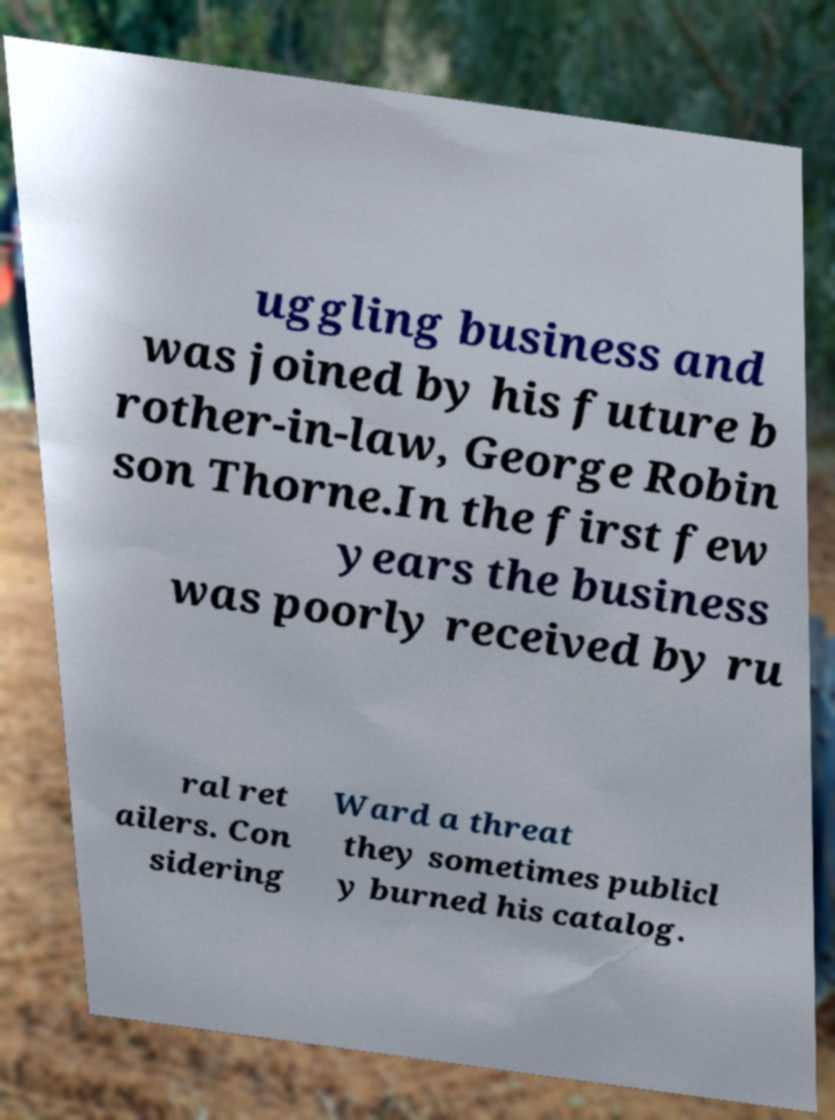What messages or text are displayed in this image? I need them in a readable, typed format. uggling business and was joined by his future b rother-in-law, George Robin son Thorne.In the first few years the business was poorly received by ru ral ret ailers. Con sidering Ward a threat they sometimes publicl y burned his catalog. 